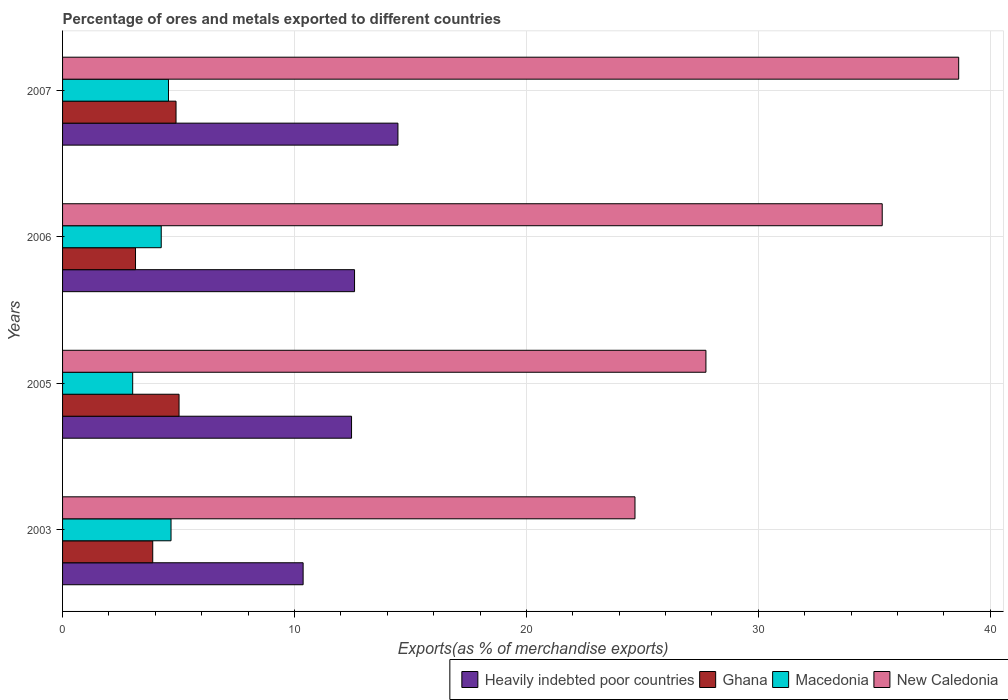How many different coloured bars are there?
Your answer should be compact. 4. Are the number of bars per tick equal to the number of legend labels?
Your response must be concise. Yes. Are the number of bars on each tick of the Y-axis equal?
Make the answer very short. Yes. How many bars are there on the 4th tick from the bottom?
Your answer should be very brief. 4. What is the label of the 3rd group of bars from the top?
Provide a succinct answer. 2005. What is the percentage of exports to different countries in Heavily indebted poor countries in 2006?
Offer a terse response. 12.59. Across all years, what is the maximum percentage of exports to different countries in Heavily indebted poor countries?
Give a very brief answer. 14.46. Across all years, what is the minimum percentage of exports to different countries in New Caledonia?
Ensure brevity in your answer.  24.68. What is the total percentage of exports to different countries in Heavily indebted poor countries in the graph?
Make the answer very short. 49.88. What is the difference between the percentage of exports to different countries in Heavily indebted poor countries in 2005 and that in 2007?
Offer a terse response. -2. What is the difference between the percentage of exports to different countries in New Caledonia in 2006 and the percentage of exports to different countries in Ghana in 2005?
Offer a terse response. 30.32. What is the average percentage of exports to different countries in Macedonia per year?
Offer a very short reply. 4.13. In the year 2003, what is the difference between the percentage of exports to different countries in Ghana and percentage of exports to different countries in Macedonia?
Make the answer very short. -0.79. In how many years, is the percentage of exports to different countries in Macedonia greater than 22 %?
Make the answer very short. 0. What is the ratio of the percentage of exports to different countries in Heavily indebted poor countries in 2006 to that in 2007?
Provide a succinct answer. 0.87. What is the difference between the highest and the second highest percentage of exports to different countries in Heavily indebted poor countries?
Provide a short and direct response. 1.87. What is the difference between the highest and the lowest percentage of exports to different countries in Heavily indebted poor countries?
Your answer should be very brief. 4.09. What does the 3rd bar from the top in 2006 represents?
Ensure brevity in your answer.  Ghana. What does the 3rd bar from the bottom in 2007 represents?
Your answer should be compact. Macedonia. Is it the case that in every year, the sum of the percentage of exports to different countries in Macedonia and percentage of exports to different countries in New Caledonia is greater than the percentage of exports to different countries in Heavily indebted poor countries?
Keep it short and to the point. Yes. How many bars are there?
Offer a very short reply. 16. Does the graph contain any zero values?
Provide a short and direct response. No. Does the graph contain grids?
Provide a short and direct response. Yes. Where does the legend appear in the graph?
Provide a short and direct response. Bottom right. How are the legend labels stacked?
Your answer should be very brief. Horizontal. What is the title of the graph?
Your answer should be compact. Percentage of ores and metals exported to different countries. Does "West Bank and Gaza" appear as one of the legend labels in the graph?
Ensure brevity in your answer.  No. What is the label or title of the X-axis?
Your response must be concise. Exports(as % of merchandise exports). What is the label or title of the Y-axis?
Make the answer very short. Years. What is the Exports(as % of merchandise exports) in Heavily indebted poor countries in 2003?
Your answer should be compact. 10.37. What is the Exports(as % of merchandise exports) of Ghana in 2003?
Your answer should be very brief. 3.89. What is the Exports(as % of merchandise exports) in Macedonia in 2003?
Your response must be concise. 4.68. What is the Exports(as % of merchandise exports) in New Caledonia in 2003?
Ensure brevity in your answer.  24.68. What is the Exports(as % of merchandise exports) in Heavily indebted poor countries in 2005?
Offer a very short reply. 12.46. What is the Exports(as % of merchandise exports) of Ghana in 2005?
Provide a succinct answer. 5.02. What is the Exports(as % of merchandise exports) of Macedonia in 2005?
Give a very brief answer. 3.02. What is the Exports(as % of merchandise exports) in New Caledonia in 2005?
Your answer should be very brief. 27.74. What is the Exports(as % of merchandise exports) in Heavily indebted poor countries in 2006?
Your answer should be compact. 12.59. What is the Exports(as % of merchandise exports) of Ghana in 2006?
Offer a terse response. 3.15. What is the Exports(as % of merchandise exports) in Macedonia in 2006?
Offer a very short reply. 4.25. What is the Exports(as % of merchandise exports) in New Caledonia in 2006?
Offer a terse response. 35.34. What is the Exports(as % of merchandise exports) in Heavily indebted poor countries in 2007?
Ensure brevity in your answer.  14.46. What is the Exports(as % of merchandise exports) in Ghana in 2007?
Give a very brief answer. 4.89. What is the Exports(as % of merchandise exports) in Macedonia in 2007?
Offer a very short reply. 4.57. What is the Exports(as % of merchandise exports) in New Caledonia in 2007?
Your answer should be compact. 38.64. Across all years, what is the maximum Exports(as % of merchandise exports) in Heavily indebted poor countries?
Give a very brief answer. 14.46. Across all years, what is the maximum Exports(as % of merchandise exports) in Ghana?
Your answer should be very brief. 5.02. Across all years, what is the maximum Exports(as % of merchandise exports) in Macedonia?
Your response must be concise. 4.68. Across all years, what is the maximum Exports(as % of merchandise exports) in New Caledonia?
Provide a succinct answer. 38.64. Across all years, what is the minimum Exports(as % of merchandise exports) in Heavily indebted poor countries?
Ensure brevity in your answer.  10.37. Across all years, what is the minimum Exports(as % of merchandise exports) in Ghana?
Provide a short and direct response. 3.15. Across all years, what is the minimum Exports(as % of merchandise exports) in Macedonia?
Provide a succinct answer. 3.02. Across all years, what is the minimum Exports(as % of merchandise exports) in New Caledonia?
Provide a succinct answer. 24.68. What is the total Exports(as % of merchandise exports) of Heavily indebted poor countries in the graph?
Make the answer very short. 49.88. What is the total Exports(as % of merchandise exports) of Ghana in the graph?
Your answer should be compact. 16.95. What is the total Exports(as % of merchandise exports) in Macedonia in the graph?
Give a very brief answer. 16.52. What is the total Exports(as % of merchandise exports) of New Caledonia in the graph?
Offer a very short reply. 126.4. What is the difference between the Exports(as % of merchandise exports) of Heavily indebted poor countries in 2003 and that in 2005?
Your answer should be compact. -2.09. What is the difference between the Exports(as % of merchandise exports) of Ghana in 2003 and that in 2005?
Give a very brief answer. -1.14. What is the difference between the Exports(as % of merchandise exports) in Macedonia in 2003 and that in 2005?
Your answer should be compact. 1.65. What is the difference between the Exports(as % of merchandise exports) of New Caledonia in 2003 and that in 2005?
Provide a short and direct response. -3.06. What is the difference between the Exports(as % of merchandise exports) in Heavily indebted poor countries in 2003 and that in 2006?
Keep it short and to the point. -2.22. What is the difference between the Exports(as % of merchandise exports) of Ghana in 2003 and that in 2006?
Your answer should be compact. 0.74. What is the difference between the Exports(as % of merchandise exports) in Macedonia in 2003 and that in 2006?
Your answer should be very brief. 0.42. What is the difference between the Exports(as % of merchandise exports) in New Caledonia in 2003 and that in 2006?
Offer a very short reply. -10.66. What is the difference between the Exports(as % of merchandise exports) of Heavily indebted poor countries in 2003 and that in 2007?
Keep it short and to the point. -4.09. What is the difference between the Exports(as % of merchandise exports) in Ghana in 2003 and that in 2007?
Provide a short and direct response. -1. What is the difference between the Exports(as % of merchandise exports) of Macedonia in 2003 and that in 2007?
Your answer should be very brief. 0.11. What is the difference between the Exports(as % of merchandise exports) in New Caledonia in 2003 and that in 2007?
Ensure brevity in your answer.  -13.96. What is the difference between the Exports(as % of merchandise exports) of Heavily indebted poor countries in 2005 and that in 2006?
Your answer should be compact. -0.13. What is the difference between the Exports(as % of merchandise exports) in Ghana in 2005 and that in 2006?
Provide a short and direct response. 1.88. What is the difference between the Exports(as % of merchandise exports) of Macedonia in 2005 and that in 2006?
Make the answer very short. -1.23. What is the difference between the Exports(as % of merchandise exports) of New Caledonia in 2005 and that in 2006?
Offer a very short reply. -7.6. What is the difference between the Exports(as % of merchandise exports) of Heavily indebted poor countries in 2005 and that in 2007?
Your response must be concise. -2. What is the difference between the Exports(as % of merchandise exports) in Ghana in 2005 and that in 2007?
Provide a succinct answer. 0.13. What is the difference between the Exports(as % of merchandise exports) of Macedonia in 2005 and that in 2007?
Offer a very short reply. -1.54. What is the difference between the Exports(as % of merchandise exports) of New Caledonia in 2005 and that in 2007?
Provide a short and direct response. -10.9. What is the difference between the Exports(as % of merchandise exports) of Heavily indebted poor countries in 2006 and that in 2007?
Offer a very short reply. -1.87. What is the difference between the Exports(as % of merchandise exports) in Ghana in 2006 and that in 2007?
Offer a very short reply. -1.75. What is the difference between the Exports(as % of merchandise exports) in Macedonia in 2006 and that in 2007?
Offer a very short reply. -0.31. What is the difference between the Exports(as % of merchandise exports) in New Caledonia in 2006 and that in 2007?
Offer a terse response. -3.3. What is the difference between the Exports(as % of merchandise exports) in Heavily indebted poor countries in 2003 and the Exports(as % of merchandise exports) in Ghana in 2005?
Offer a terse response. 5.35. What is the difference between the Exports(as % of merchandise exports) in Heavily indebted poor countries in 2003 and the Exports(as % of merchandise exports) in Macedonia in 2005?
Make the answer very short. 7.35. What is the difference between the Exports(as % of merchandise exports) of Heavily indebted poor countries in 2003 and the Exports(as % of merchandise exports) of New Caledonia in 2005?
Give a very brief answer. -17.37. What is the difference between the Exports(as % of merchandise exports) in Ghana in 2003 and the Exports(as % of merchandise exports) in Macedonia in 2005?
Offer a terse response. 0.86. What is the difference between the Exports(as % of merchandise exports) in Ghana in 2003 and the Exports(as % of merchandise exports) in New Caledonia in 2005?
Provide a short and direct response. -23.85. What is the difference between the Exports(as % of merchandise exports) in Macedonia in 2003 and the Exports(as % of merchandise exports) in New Caledonia in 2005?
Give a very brief answer. -23.06. What is the difference between the Exports(as % of merchandise exports) in Heavily indebted poor countries in 2003 and the Exports(as % of merchandise exports) in Ghana in 2006?
Give a very brief answer. 7.23. What is the difference between the Exports(as % of merchandise exports) of Heavily indebted poor countries in 2003 and the Exports(as % of merchandise exports) of Macedonia in 2006?
Your answer should be compact. 6.12. What is the difference between the Exports(as % of merchandise exports) in Heavily indebted poor countries in 2003 and the Exports(as % of merchandise exports) in New Caledonia in 2006?
Provide a short and direct response. -24.97. What is the difference between the Exports(as % of merchandise exports) of Ghana in 2003 and the Exports(as % of merchandise exports) of Macedonia in 2006?
Your answer should be compact. -0.37. What is the difference between the Exports(as % of merchandise exports) in Ghana in 2003 and the Exports(as % of merchandise exports) in New Caledonia in 2006?
Offer a very short reply. -31.45. What is the difference between the Exports(as % of merchandise exports) of Macedonia in 2003 and the Exports(as % of merchandise exports) of New Caledonia in 2006?
Offer a terse response. -30.66. What is the difference between the Exports(as % of merchandise exports) of Heavily indebted poor countries in 2003 and the Exports(as % of merchandise exports) of Ghana in 2007?
Your response must be concise. 5.48. What is the difference between the Exports(as % of merchandise exports) in Heavily indebted poor countries in 2003 and the Exports(as % of merchandise exports) in Macedonia in 2007?
Your answer should be compact. 5.81. What is the difference between the Exports(as % of merchandise exports) in Heavily indebted poor countries in 2003 and the Exports(as % of merchandise exports) in New Caledonia in 2007?
Your answer should be very brief. -28.27. What is the difference between the Exports(as % of merchandise exports) in Ghana in 2003 and the Exports(as % of merchandise exports) in Macedonia in 2007?
Ensure brevity in your answer.  -0.68. What is the difference between the Exports(as % of merchandise exports) of Ghana in 2003 and the Exports(as % of merchandise exports) of New Caledonia in 2007?
Give a very brief answer. -34.75. What is the difference between the Exports(as % of merchandise exports) of Macedonia in 2003 and the Exports(as % of merchandise exports) of New Caledonia in 2007?
Make the answer very short. -33.96. What is the difference between the Exports(as % of merchandise exports) in Heavily indebted poor countries in 2005 and the Exports(as % of merchandise exports) in Ghana in 2006?
Your response must be concise. 9.31. What is the difference between the Exports(as % of merchandise exports) of Heavily indebted poor countries in 2005 and the Exports(as % of merchandise exports) of Macedonia in 2006?
Your answer should be very brief. 8.21. What is the difference between the Exports(as % of merchandise exports) of Heavily indebted poor countries in 2005 and the Exports(as % of merchandise exports) of New Caledonia in 2006?
Your response must be concise. -22.88. What is the difference between the Exports(as % of merchandise exports) in Ghana in 2005 and the Exports(as % of merchandise exports) in Macedonia in 2006?
Keep it short and to the point. 0.77. What is the difference between the Exports(as % of merchandise exports) of Ghana in 2005 and the Exports(as % of merchandise exports) of New Caledonia in 2006?
Give a very brief answer. -30.32. What is the difference between the Exports(as % of merchandise exports) in Macedonia in 2005 and the Exports(as % of merchandise exports) in New Caledonia in 2006?
Make the answer very short. -32.32. What is the difference between the Exports(as % of merchandise exports) of Heavily indebted poor countries in 2005 and the Exports(as % of merchandise exports) of Ghana in 2007?
Your response must be concise. 7.57. What is the difference between the Exports(as % of merchandise exports) in Heavily indebted poor countries in 2005 and the Exports(as % of merchandise exports) in Macedonia in 2007?
Give a very brief answer. 7.89. What is the difference between the Exports(as % of merchandise exports) in Heavily indebted poor countries in 2005 and the Exports(as % of merchandise exports) in New Caledonia in 2007?
Ensure brevity in your answer.  -26.18. What is the difference between the Exports(as % of merchandise exports) of Ghana in 2005 and the Exports(as % of merchandise exports) of Macedonia in 2007?
Keep it short and to the point. 0.46. What is the difference between the Exports(as % of merchandise exports) of Ghana in 2005 and the Exports(as % of merchandise exports) of New Caledonia in 2007?
Ensure brevity in your answer.  -33.62. What is the difference between the Exports(as % of merchandise exports) in Macedonia in 2005 and the Exports(as % of merchandise exports) in New Caledonia in 2007?
Provide a short and direct response. -35.61. What is the difference between the Exports(as % of merchandise exports) of Heavily indebted poor countries in 2006 and the Exports(as % of merchandise exports) of Ghana in 2007?
Provide a succinct answer. 7.7. What is the difference between the Exports(as % of merchandise exports) of Heavily indebted poor countries in 2006 and the Exports(as % of merchandise exports) of Macedonia in 2007?
Make the answer very short. 8.02. What is the difference between the Exports(as % of merchandise exports) in Heavily indebted poor countries in 2006 and the Exports(as % of merchandise exports) in New Caledonia in 2007?
Keep it short and to the point. -26.05. What is the difference between the Exports(as % of merchandise exports) in Ghana in 2006 and the Exports(as % of merchandise exports) in Macedonia in 2007?
Provide a short and direct response. -1.42. What is the difference between the Exports(as % of merchandise exports) in Ghana in 2006 and the Exports(as % of merchandise exports) in New Caledonia in 2007?
Your answer should be very brief. -35.49. What is the difference between the Exports(as % of merchandise exports) in Macedonia in 2006 and the Exports(as % of merchandise exports) in New Caledonia in 2007?
Your answer should be very brief. -34.38. What is the average Exports(as % of merchandise exports) of Heavily indebted poor countries per year?
Provide a succinct answer. 12.47. What is the average Exports(as % of merchandise exports) in Ghana per year?
Provide a short and direct response. 4.24. What is the average Exports(as % of merchandise exports) of Macedonia per year?
Ensure brevity in your answer.  4.13. What is the average Exports(as % of merchandise exports) in New Caledonia per year?
Keep it short and to the point. 31.6. In the year 2003, what is the difference between the Exports(as % of merchandise exports) in Heavily indebted poor countries and Exports(as % of merchandise exports) in Ghana?
Ensure brevity in your answer.  6.48. In the year 2003, what is the difference between the Exports(as % of merchandise exports) of Heavily indebted poor countries and Exports(as % of merchandise exports) of Macedonia?
Offer a very short reply. 5.7. In the year 2003, what is the difference between the Exports(as % of merchandise exports) of Heavily indebted poor countries and Exports(as % of merchandise exports) of New Caledonia?
Your answer should be very brief. -14.31. In the year 2003, what is the difference between the Exports(as % of merchandise exports) in Ghana and Exports(as % of merchandise exports) in Macedonia?
Offer a very short reply. -0.79. In the year 2003, what is the difference between the Exports(as % of merchandise exports) in Ghana and Exports(as % of merchandise exports) in New Caledonia?
Provide a short and direct response. -20.79. In the year 2003, what is the difference between the Exports(as % of merchandise exports) in Macedonia and Exports(as % of merchandise exports) in New Caledonia?
Ensure brevity in your answer.  -20. In the year 2005, what is the difference between the Exports(as % of merchandise exports) in Heavily indebted poor countries and Exports(as % of merchandise exports) in Ghana?
Your answer should be very brief. 7.44. In the year 2005, what is the difference between the Exports(as % of merchandise exports) of Heavily indebted poor countries and Exports(as % of merchandise exports) of Macedonia?
Offer a terse response. 9.44. In the year 2005, what is the difference between the Exports(as % of merchandise exports) of Heavily indebted poor countries and Exports(as % of merchandise exports) of New Caledonia?
Offer a very short reply. -15.28. In the year 2005, what is the difference between the Exports(as % of merchandise exports) in Ghana and Exports(as % of merchandise exports) in Macedonia?
Your answer should be very brief. 2. In the year 2005, what is the difference between the Exports(as % of merchandise exports) of Ghana and Exports(as % of merchandise exports) of New Caledonia?
Your answer should be compact. -22.72. In the year 2005, what is the difference between the Exports(as % of merchandise exports) of Macedonia and Exports(as % of merchandise exports) of New Caledonia?
Your answer should be very brief. -24.72. In the year 2006, what is the difference between the Exports(as % of merchandise exports) in Heavily indebted poor countries and Exports(as % of merchandise exports) in Ghana?
Provide a succinct answer. 9.44. In the year 2006, what is the difference between the Exports(as % of merchandise exports) of Heavily indebted poor countries and Exports(as % of merchandise exports) of Macedonia?
Make the answer very short. 8.34. In the year 2006, what is the difference between the Exports(as % of merchandise exports) of Heavily indebted poor countries and Exports(as % of merchandise exports) of New Caledonia?
Provide a succinct answer. -22.75. In the year 2006, what is the difference between the Exports(as % of merchandise exports) of Ghana and Exports(as % of merchandise exports) of Macedonia?
Your answer should be very brief. -1.11. In the year 2006, what is the difference between the Exports(as % of merchandise exports) in Ghana and Exports(as % of merchandise exports) in New Caledonia?
Give a very brief answer. -32.2. In the year 2006, what is the difference between the Exports(as % of merchandise exports) in Macedonia and Exports(as % of merchandise exports) in New Caledonia?
Provide a succinct answer. -31.09. In the year 2007, what is the difference between the Exports(as % of merchandise exports) in Heavily indebted poor countries and Exports(as % of merchandise exports) in Ghana?
Offer a terse response. 9.57. In the year 2007, what is the difference between the Exports(as % of merchandise exports) in Heavily indebted poor countries and Exports(as % of merchandise exports) in Macedonia?
Make the answer very short. 9.89. In the year 2007, what is the difference between the Exports(as % of merchandise exports) of Heavily indebted poor countries and Exports(as % of merchandise exports) of New Caledonia?
Your response must be concise. -24.18. In the year 2007, what is the difference between the Exports(as % of merchandise exports) of Ghana and Exports(as % of merchandise exports) of Macedonia?
Provide a succinct answer. 0.33. In the year 2007, what is the difference between the Exports(as % of merchandise exports) of Ghana and Exports(as % of merchandise exports) of New Caledonia?
Ensure brevity in your answer.  -33.75. In the year 2007, what is the difference between the Exports(as % of merchandise exports) in Macedonia and Exports(as % of merchandise exports) in New Caledonia?
Provide a short and direct response. -34.07. What is the ratio of the Exports(as % of merchandise exports) in Heavily indebted poor countries in 2003 to that in 2005?
Offer a terse response. 0.83. What is the ratio of the Exports(as % of merchandise exports) in Ghana in 2003 to that in 2005?
Keep it short and to the point. 0.77. What is the ratio of the Exports(as % of merchandise exports) of Macedonia in 2003 to that in 2005?
Provide a succinct answer. 1.55. What is the ratio of the Exports(as % of merchandise exports) in New Caledonia in 2003 to that in 2005?
Ensure brevity in your answer.  0.89. What is the ratio of the Exports(as % of merchandise exports) in Heavily indebted poor countries in 2003 to that in 2006?
Give a very brief answer. 0.82. What is the ratio of the Exports(as % of merchandise exports) in Ghana in 2003 to that in 2006?
Provide a succinct answer. 1.24. What is the ratio of the Exports(as % of merchandise exports) in Macedonia in 2003 to that in 2006?
Provide a short and direct response. 1.1. What is the ratio of the Exports(as % of merchandise exports) of New Caledonia in 2003 to that in 2006?
Your answer should be very brief. 0.7. What is the ratio of the Exports(as % of merchandise exports) in Heavily indebted poor countries in 2003 to that in 2007?
Give a very brief answer. 0.72. What is the ratio of the Exports(as % of merchandise exports) in Ghana in 2003 to that in 2007?
Provide a succinct answer. 0.79. What is the ratio of the Exports(as % of merchandise exports) in Macedonia in 2003 to that in 2007?
Your answer should be very brief. 1.02. What is the ratio of the Exports(as % of merchandise exports) in New Caledonia in 2003 to that in 2007?
Ensure brevity in your answer.  0.64. What is the ratio of the Exports(as % of merchandise exports) of Ghana in 2005 to that in 2006?
Make the answer very short. 1.6. What is the ratio of the Exports(as % of merchandise exports) in Macedonia in 2005 to that in 2006?
Offer a very short reply. 0.71. What is the ratio of the Exports(as % of merchandise exports) in New Caledonia in 2005 to that in 2006?
Give a very brief answer. 0.78. What is the ratio of the Exports(as % of merchandise exports) of Heavily indebted poor countries in 2005 to that in 2007?
Offer a terse response. 0.86. What is the ratio of the Exports(as % of merchandise exports) of Ghana in 2005 to that in 2007?
Give a very brief answer. 1.03. What is the ratio of the Exports(as % of merchandise exports) of Macedonia in 2005 to that in 2007?
Offer a very short reply. 0.66. What is the ratio of the Exports(as % of merchandise exports) in New Caledonia in 2005 to that in 2007?
Provide a succinct answer. 0.72. What is the ratio of the Exports(as % of merchandise exports) in Heavily indebted poor countries in 2006 to that in 2007?
Your response must be concise. 0.87. What is the ratio of the Exports(as % of merchandise exports) in Ghana in 2006 to that in 2007?
Provide a succinct answer. 0.64. What is the ratio of the Exports(as % of merchandise exports) of Macedonia in 2006 to that in 2007?
Your answer should be compact. 0.93. What is the ratio of the Exports(as % of merchandise exports) in New Caledonia in 2006 to that in 2007?
Offer a very short reply. 0.91. What is the difference between the highest and the second highest Exports(as % of merchandise exports) in Heavily indebted poor countries?
Ensure brevity in your answer.  1.87. What is the difference between the highest and the second highest Exports(as % of merchandise exports) of Ghana?
Provide a short and direct response. 0.13. What is the difference between the highest and the second highest Exports(as % of merchandise exports) in Macedonia?
Your answer should be very brief. 0.11. What is the difference between the highest and the second highest Exports(as % of merchandise exports) of New Caledonia?
Ensure brevity in your answer.  3.3. What is the difference between the highest and the lowest Exports(as % of merchandise exports) in Heavily indebted poor countries?
Make the answer very short. 4.09. What is the difference between the highest and the lowest Exports(as % of merchandise exports) of Ghana?
Provide a short and direct response. 1.88. What is the difference between the highest and the lowest Exports(as % of merchandise exports) of Macedonia?
Your response must be concise. 1.65. What is the difference between the highest and the lowest Exports(as % of merchandise exports) of New Caledonia?
Offer a very short reply. 13.96. 